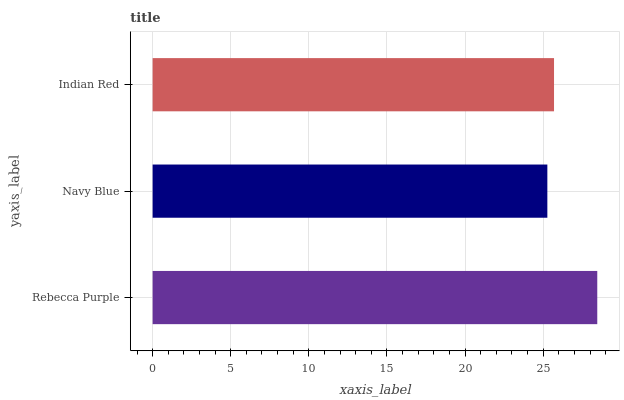Is Navy Blue the minimum?
Answer yes or no. Yes. Is Rebecca Purple the maximum?
Answer yes or no. Yes. Is Indian Red the minimum?
Answer yes or no. No. Is Indian Red the maximum?
Answer yes or no. No. Is Indian Red greater than Navy Blue?
Answer yes or no. Yes. Is Navy Blue less than Indian Red?
Answer yes or no. Yes. Is Navy Blue greater than Indian Red?
Answer yes or no. No. Is Indian Red less than Navy Blue?
Answer yes or no. No. Is Indian Red the high median?
Answer yes or no. Yes. Is Indian Red the low median?
Answer yes or no. Yes. Is Navy Blue the high median?
Answer yes or no. No. Is Navy Blue the low median?
Answer yes or no. No. 